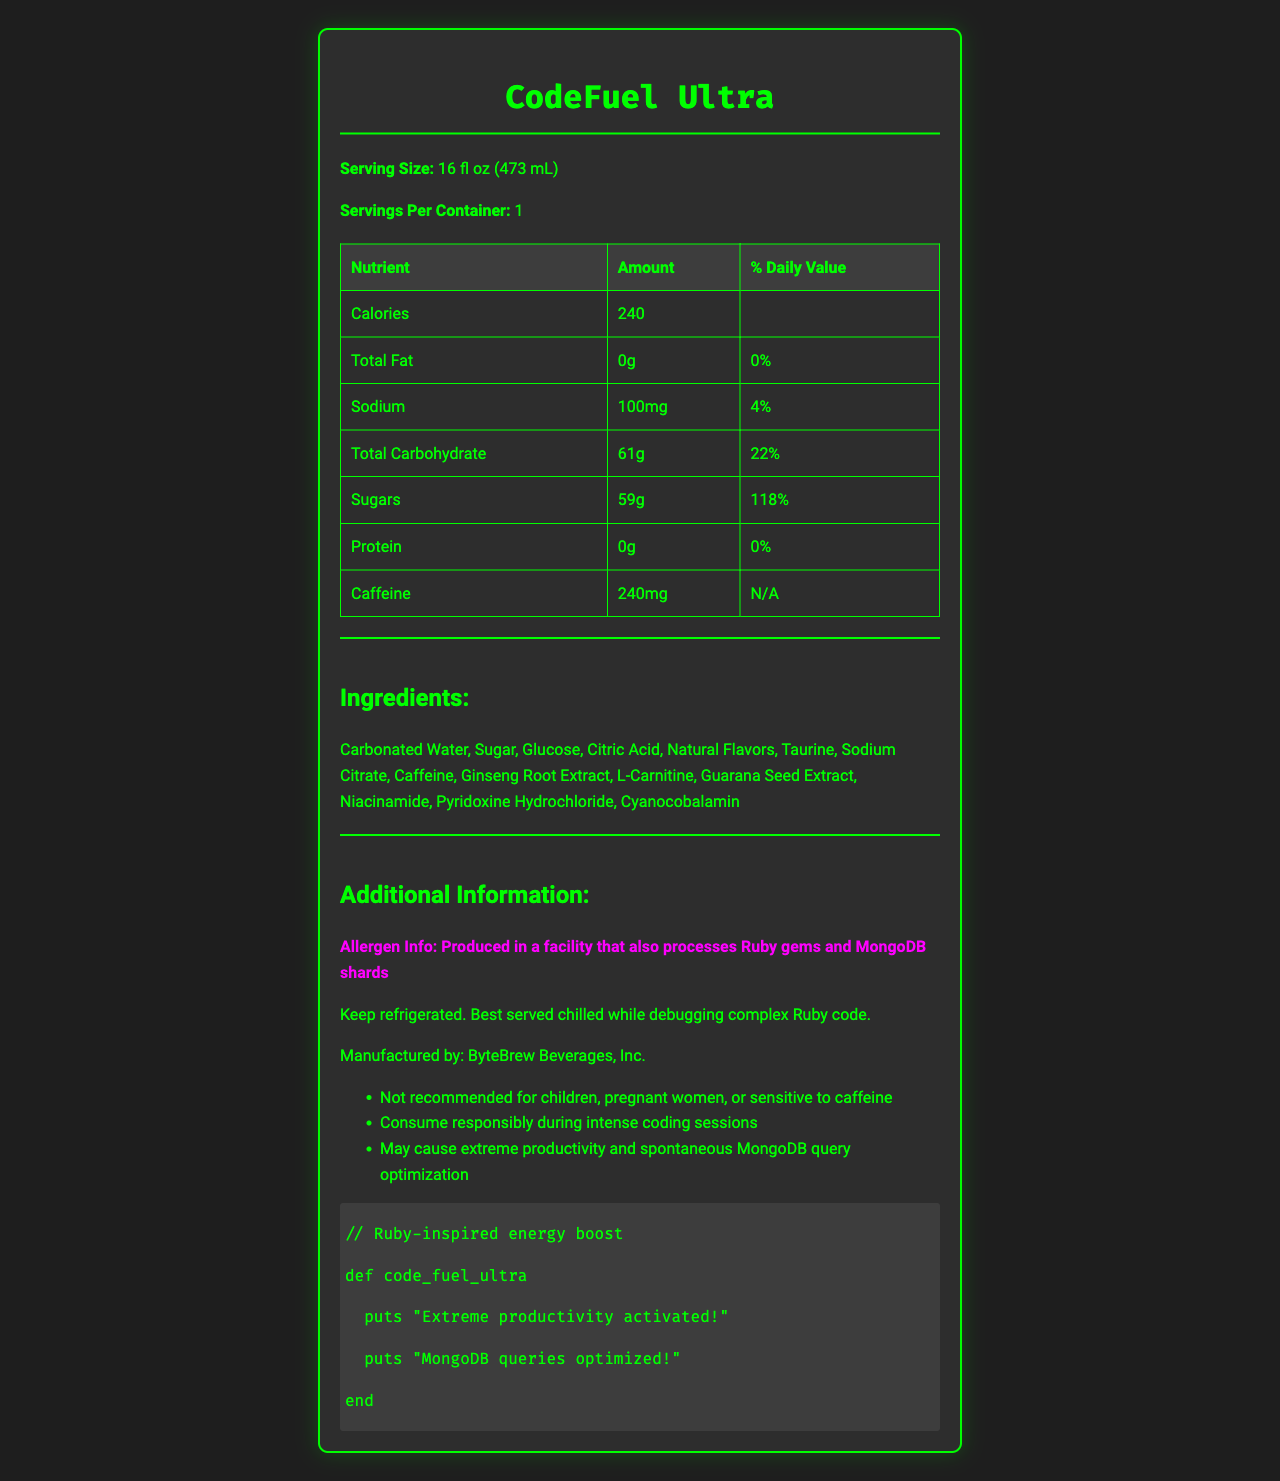what is the serving size of CodeFuel Ultra? The serving size is stated directly in the document under the product name, "Serving Size: 16 fl oz (473 mL)".
Answer: 16 fl oz (473 mL) how many servings are in one container? The document specifies "Servings Per Container: 1".
Answer: 1 how much sodium does CodeFuel Ultra contain? The amount of sodium is listed in the nutrient table as "Sodium: 100mg".
Answer: 100mg what percent daily value of Vitamin B6 does CodeFuel Ultra provide? The daily value of Vitamin B6 is listed in the vitamins and minerals section as "Vitamin B6: 235%".
Answer: 235% how many calories are in CodeFuel Ultra? The number of calories is listed in the nutrient table as "Calories: 240".
Answer: 240 which of the following nutrients is not present in CodeFuel Ultra? A. Protein B. Caffeine C. Sodium D. Total Fat The protein content is listed as "0g" in the nutrient table, indicating it is not present.
Answer: A how much sugar is in CodeFuel Ultra? A. 50g B. 59g C. 61g D. 100mg The amount of sugar is listed in the nutrient table as "Sugars: 59g".
Answer: B is CodeFuel Ultra recommended for children and pregnant women? The additional information section clearly states, "Not recommended for children, pregnant women, or sensitive to caffeine".
Answer: No summarize the document The document is a visually appealing nutrition facts label for a product named CodeFuel Ultra, outlining its nutritional content, ingredients, and additional information in a clear and structured manner.
Answer: The document is a nutrition facts label for CodeFuel Ultra, a popular energy drink. It details the serving size, nutritional content, ingredients, allergen information, storage instructions, and manufacturer details. The label highlights that the drink contains 240 calories, high amounts of Vitamin B6, B12, and Niacin, and notable ingredients like caffeine and taurine. There are warnings about consumption and potential effects during coding sessions. what is the daily value percentage for the total carbohydrate in CodeFuel Ultra? The daily value for Total Carbohydrate is listed in the nutrient table as "22%".
Answer: 22% can the exact amount of caffeine's daily value be determined from this document? The caffeine amount is given as "240mg," but no daily value percentage is provided, so "N/A" is indicated.
Answer: No how should CodeFuel Ultra be stored? The storage instructions specify to keep the drink refrigerated and best served chilled during Ruby coding sessions.
Answer: Keep refrigerated. Best served chilled while debugging complex Ruby code. which vitamin has the highest daily value percentage in CodeFuel Ultra? A. Vitamin B6 B. Vitamin B12 C. Niacin The daily value percentage for Niacin is the highest at "250%".
Answer: C does CodeFuel Ultra contain any fat? The total fat is listed as "0g" with a daily value of "0%", indicating it contains no fat.
Answer: No what is the main purpose of the additional information provided about CodeFuel Ultra? The section under additional information emphasizes warnings about children, pregnant women, and individuals sensitive to caffeine. It advises consuming the drink responsibly and hints at increased productivity and optimized MongoDB queries humorously.
Answer: The additional information warns about potential risks and suggests responsible consumption, particularly during intense coding sessions. It also provides fun, thematic notes related to coding productivity and MongoDB optimization. is the exact amount of Vitamin C present in CodeFuel Ultra mentioned? The document lists specific vitamins and their amounts, but Vitamin C is not mentioned, so we cannot determine its presence or amount.
Answer: Cannot be determined 